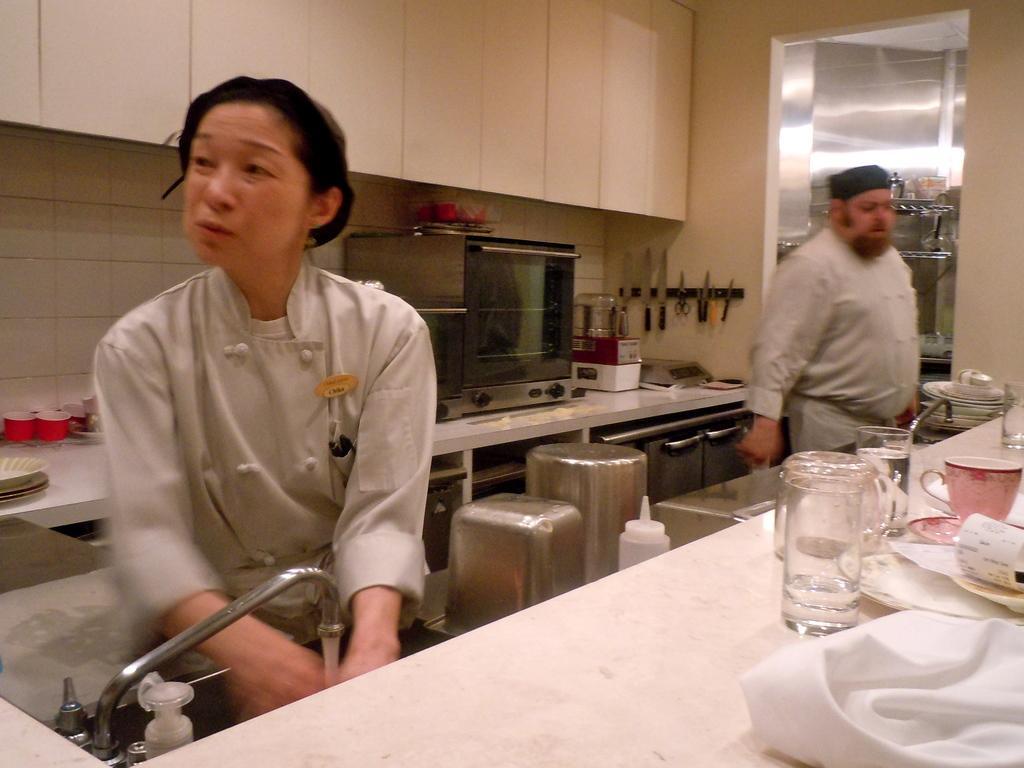Could you give a brief overview of what you see in this image? In this image in the front on the table there are glasses and there is a cloth which is white in colour and there are papers. In the center a person's standing. In the background there is a microwave oven, there is a stand, there are knives and there are wardrobes, there are cups, plates and there is a tap and there are stools. 